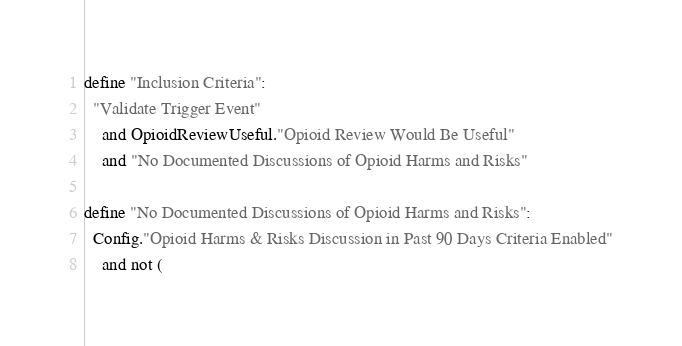<code> <loc_0><loc_0><loc_500><loc_500><_SQL_>define "Inclusion Criteria":
  "Validate Trigger Event"
    and OpioidReviewUseful."Opioid Review Would Be Useful"
    and "No Documented Discussions of Opioid Harms and Risks"

define "No Documented Discussions of Opioid Harms and Risks":
  Config."Opioid Harms & Risks Discussion in Past 90 Days Criteria Enabled"
    and not (</code> 